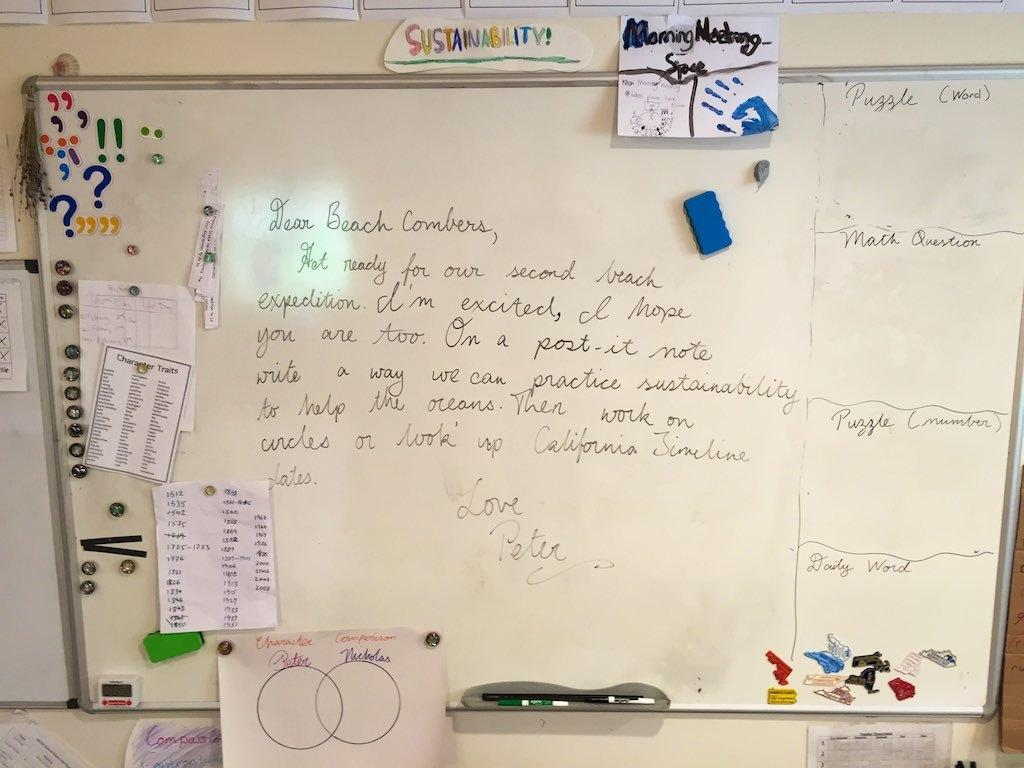<image>
Provide a brief description of the given image. A whiteboard with a messaged addressed to Beach Combers on it. 